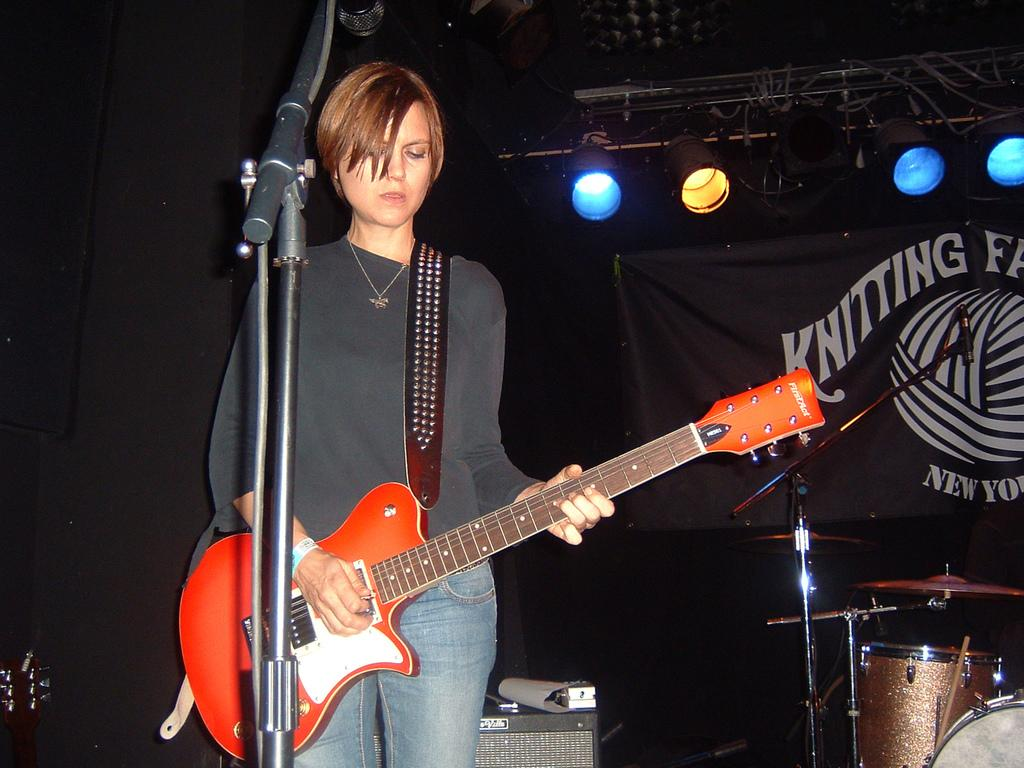Who is the main subject in the image? There is a woman in the image. What is the woman doing in the image? The woman is standing and holding a guitar in her hand. What object is in front of the woman? There is a microphone in front of the woman. What other musical instruments can be seen in the image? There are drums visible in the image. What is present at the top of the image? There are lights on the top of the image. What type of salt is sprinkled on the drums in the image? There is no salt present in the image, and the drums do not have any salt sprinkled on them. 